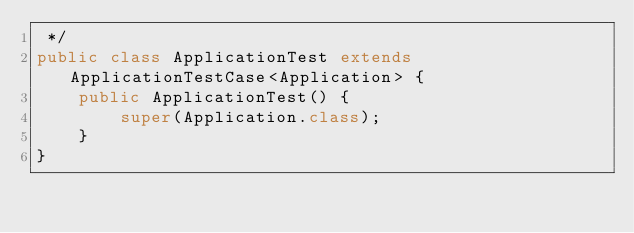<code> <loc_0><loc_0><loc_500><loc_500><_Java_> */
public class ApplicationTest extends ApplicationTestCase<Application> {
    public ApplicationTest() {
        super(Application.class);
    }
}</code> 